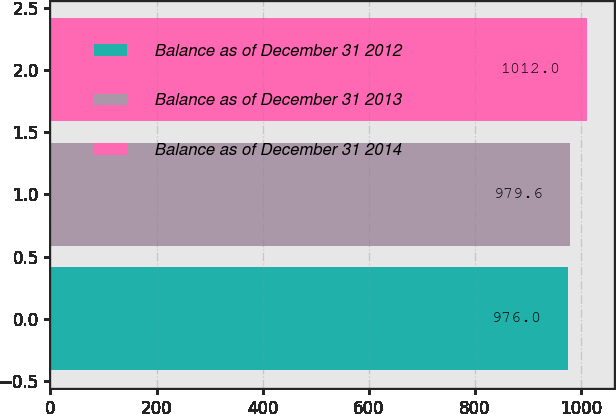Convert chart. <chart><loc_0><loc_0><loc_500><loc_500><bar_chart><fcel>Balance as of December 31 2012<fcel>Balance as of December 31 2013<fcel>Balance as of December 31 2014<nl><fcel>976<fcel>979.6<fcel>1012<nl></chart> 